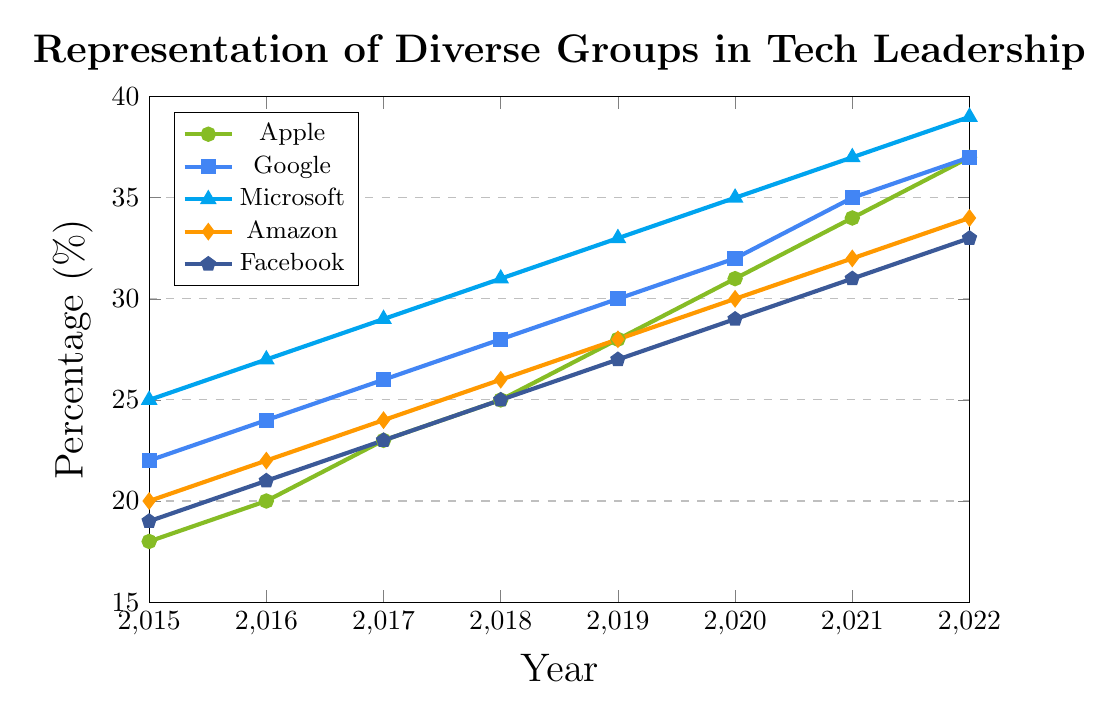What is the average percentage increase of representation for Apple from 2015 to 2022? To find the average percentage increase per year for Apple, first calculate the total percentage increase from 2015 to 2022: 37% (in 2022) - 18% (in 2015) = 19%. There are 7 year-to-year intervals from 2015 to 2022, so divide the total increase by these 7 intervals: 19% / 7 ≈ 2.71%.
Answer: 2.71% Which tech company had the highest representation of diverse groups in 2019? In 2019, the percentages are: Apple: 28%, Google: 30%, Microsoft: 33%, Amazon: 28%, Facebook: 27%. Microsoft has the highest percentage at 33%.
Answer: Microsoft Between what years did Amazon see the largest single-year percentage increase in representation? Comparing the year-to-year increases for Amazon: 2015-2016: 22% - 20% = 2%, 2016-2017: 24% - 22% = 2%, 2017-2018: 26% - 24% = 2%, 2018-2019: 28% - 26% = 2%, 2019-2020: 30% - 28% = 2%, 2020-2021: 32% - 30% = 2%, 2021-2022: 34% - 32% = 2%. Every year has the same 2% increase, so there is no single year with a larger increase.
Answer: No single year How does the representation trend for Facebook from 2015 to 2022 compare with Google's trend? From 2015 to 2022, Facebook's representation increased from 19% to 33%, a total increase of 14%. Google's representation increased from 22% to 37%, a total increase of 15%. Both companies show a positive trend, but Google's increase is slightly higher.
Answer: Google has a slightly higher total increase At which year did Microsoft first surpass 35% representation in its leadership? Looking at the data, Microsoft first surpasses 35% representation in 2020, where it reaches 35%.
Answer: 2020 How many tech companies reached at least 30% representation by 2022? In 2022, the percentages are: Apple: 37%, Google: 37%, Microsoft: 39%, Amazon: 34%, Facebook: 33%. All five companies reached at least 30% representation.
Answer: 5 companies Which company's representation percentage was closest to the average representation percentage of all companies in 2021? In 2021, the percentages are: Apple: 34%, Google: 35%, Microsoft: 37%, Amazon: 32%, Facebook: 31%. The average is (34% + 35% + 37% + 32% + 31%) / 5 = 33.8%. The closest company is Apple at 34%.
Answer: Apple What is the total increase in representation for all companies from 2015 to 2022? Calculate the total increase for each company and sum them up: Apple: 37% - 18% = 19%, Google: 37% - 22% = 15%, Microsoft: 39% - 25% = 14%, Amazon: 34% - 20% = 14%, Facebook: 33% - 19% = 14%. The total increase is 19% + 15% + 14% + 14% + 14% = 76%.
Answer: 76% Visualizing the trends, which company has the steepest upward trajectory in its line from 2015 to 2022? To determine the company with the steepest upward trajectory, we consider the slope or steepness of the line for each company. Microsoft has the highest increase in percentage points from 25% to 39%, showing the steepest upward trend.
Answer: Microsoft 